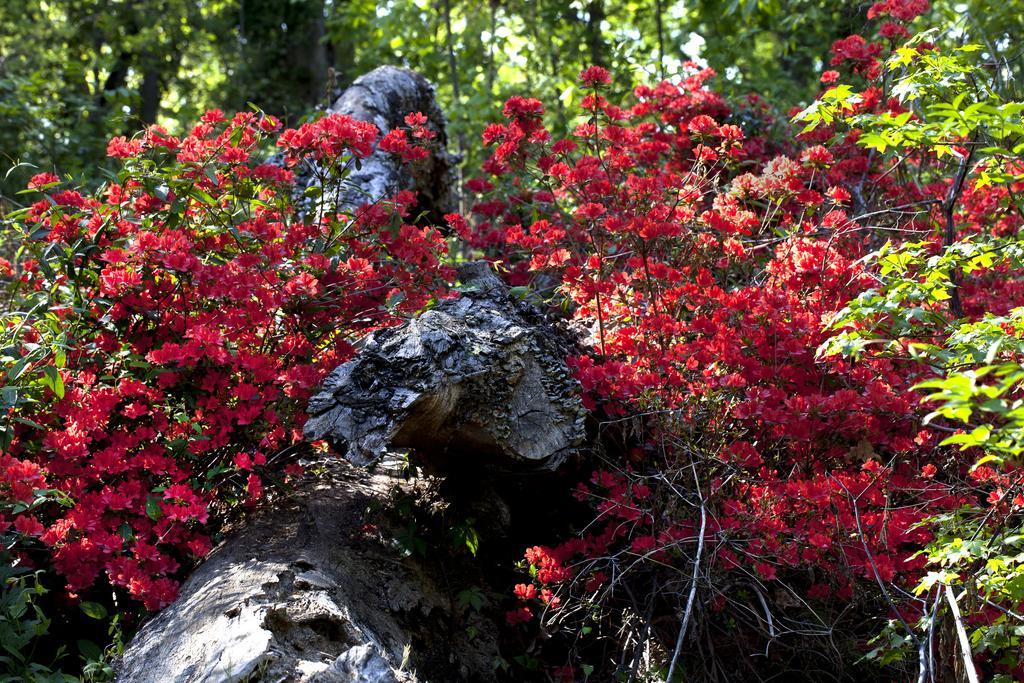Please provide a concise description of this image. In the picture we can see some plants with a flower and some rocks between the plants and in the background it is covered with some plants. 